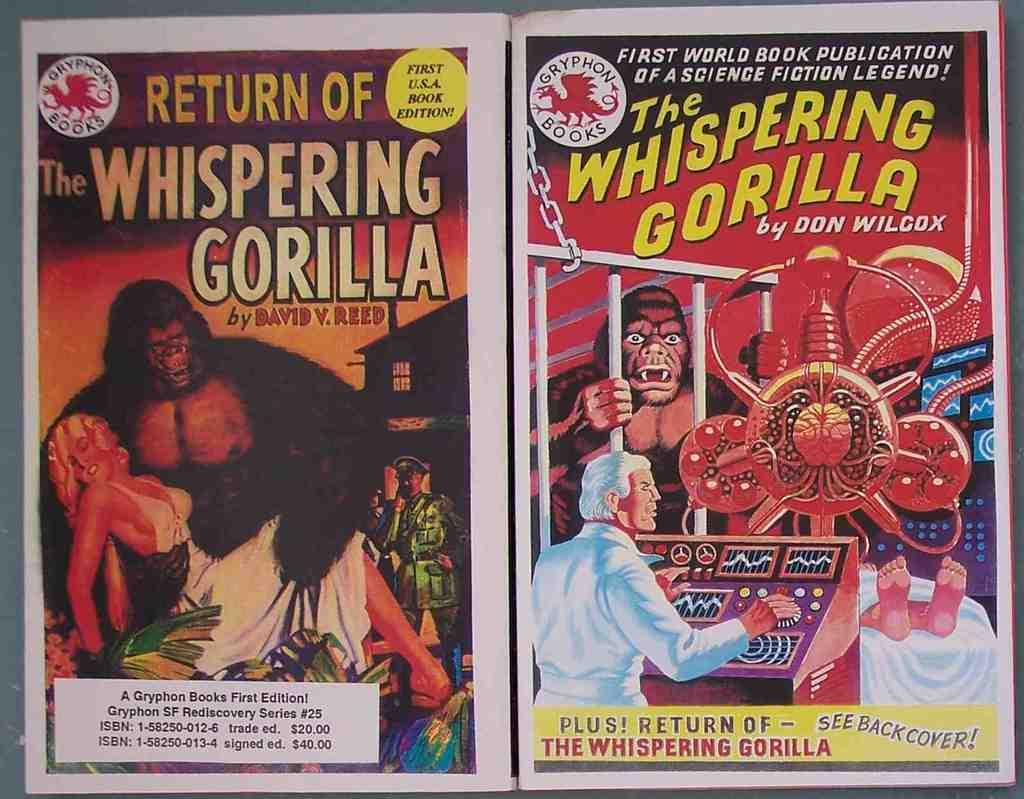What is present on the banners in the image? There are people and gorillas depicted on the banners in the image. Is there any text on the banners? Yes, there is text written on the banners. What type of leaf is being used as a cord to hang the banners in the image? There is no leaf or cord present in the image; the banners are not hanging. 